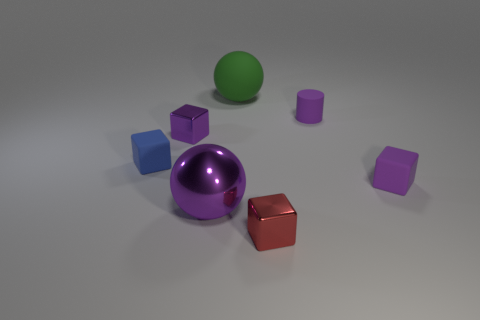What could be the possible uses for these objects in the context of learning or play? These objects could serve various educational purposes in learning or play. For instance, they could be used to help children understand geometric shapes and volumes, or for sensory play due to their different textures and materials. Additionally, they might be used in color recognition activities and sorting exercises based on shape or size. 